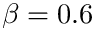Convert formula to latex. <formula><loc_0><loc_0><loc_500><loc_500>\beta = 0 . 6</formula> 